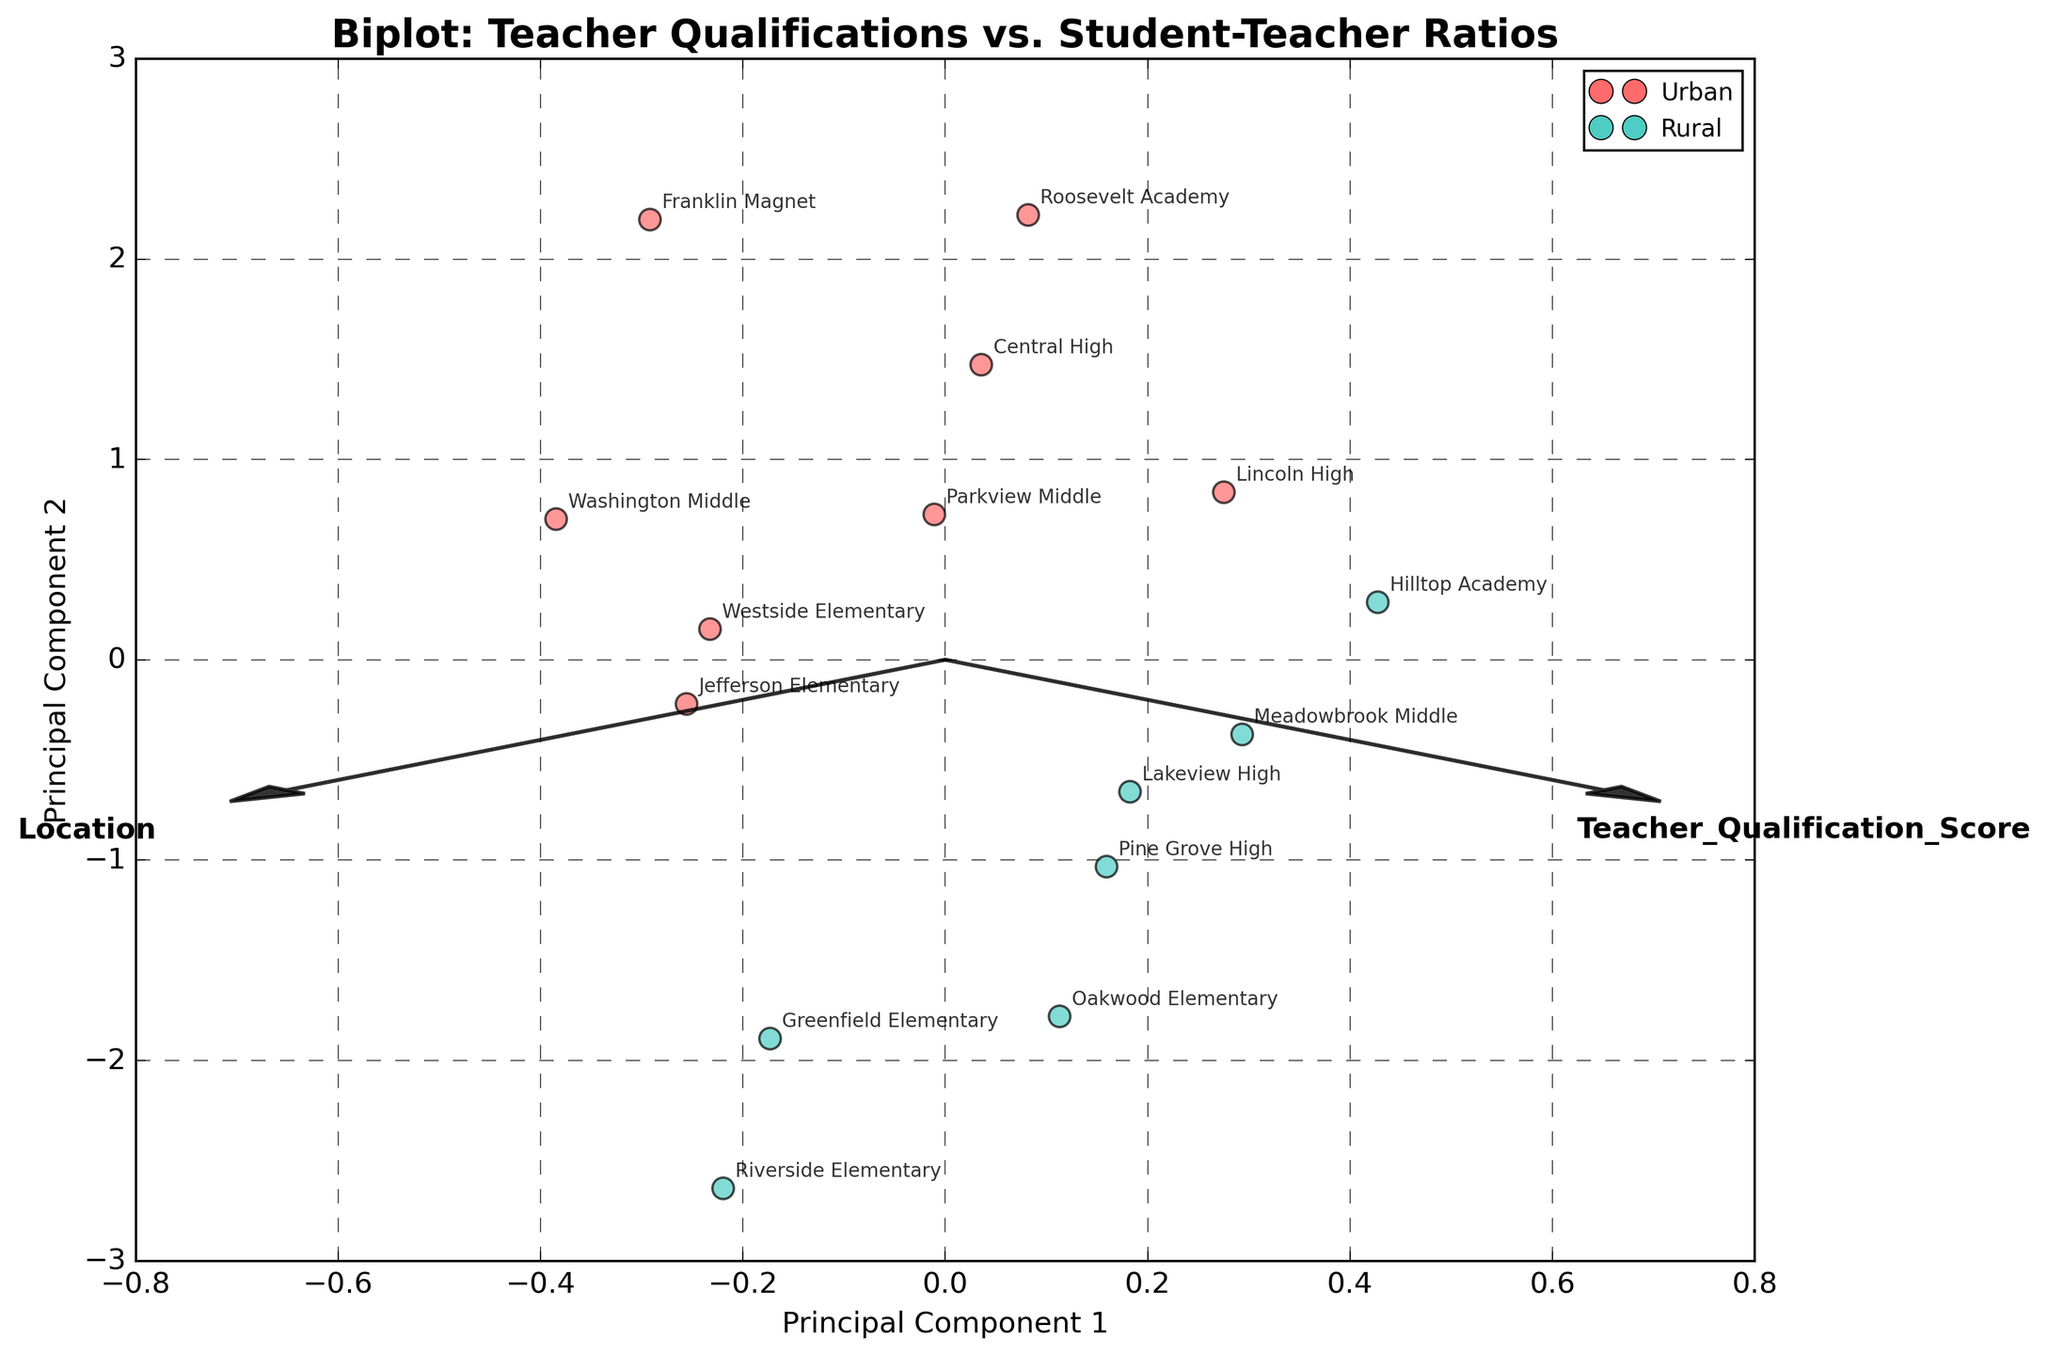Where are the labels for the axes displayed in the plot? The axes labels in the biplot are displayed at the ends of each axis. The x-axis is labeled "Principal Component 1" and the y-axis is labeled "Principal Component 2." These labels help identify the components of each principal axis.
Answer: At the ends of each axis What colors represent the Urban and Rural locations in the plot? In the biplot, Urban locations are represented by a red color, while Rural locations are represented by a teal color. The colors distinguish between the two types of locations for easy identification.
Answer: Red for Urban, Teal for Rural How many Urban and Rural schools are displayed in the plot? By counting the points with red color representing Urban locations and those with teal color representing Rural locations, we can determine the number of schools for each category. There are 8 Urban schools and 7 Rural schools shown in the plot.
Answer: 8 Urban, 7 Rural Which school has the highest Teacher Qualification Score among those displayed, and what is its Student-to-Teacher Ratio? By looking at the projection of points and their labels, Roosevelt Academy has the highest Teacher Qualification Score. It is marked at a higher position on the x and y axis. Its Student-to-Teacher Ratio is 15.
Answer: Roosevelt Academy, Ratio: 15 Compare the average Student-Teacher Ratios of Urban and Rural schools. To find the average, sum the Student-Teacher Ratios for Urban and Rural schools separately and divide by their respective counts. Urban schools (18, 22, 20, 15, 16, 17, 19, 21) sum to 148, and divided by 8 gives 18.5. Rural schools (25, 23, 21, 28, 19, 26, 22) sum to 164, and divided by 7 gives 23.4.
Answer: Urban: 18.5, Rural: 23.4 Is there a general trend between Teacher Qualification Scores and Student-Teacher Ratios in Urban and Rural schools? By observing the biplot, it appears that higher Teacher Qualification Scores tend to be associated with Urban schools, while lower scores align more with Rural schools. Additionally, Urban schools generally have lower Student-Teacher Ratios compared to Rural schools.
Answer: Urban: higher qualifications, lower ratios; Rural: lower qualifications, higher ratios Which schools are closest to the origin in the biplot? Schools closest to the origin would be those whose projections on both principal components are near zero. By looking at the plot, Jefferson Elementary (Urban) and Pine Grove High (Rural) are closest to the origin.
Answer: Jefferson Elementary, Pine Grove High Which two principal components are represented in this biplot, and what do the arrows indicate? The biplot represents Principal Component 1 and Principal Component 2. The arrows indicate the direction and magnitude of the original variables – Teacher Qualification Score and Student-Teacher Ratio – in the new principal component space.
Answer: Principal Component 1 and Principal Component 2; arrows for original variables How do the Teacher Qualification Scores of Urban schools compare to Rural schools based on their projections in the plot? The Urban schools generally show higher projections along the axis corresponding to Teacher Qualification Scores, indicating that the Urban schools have higher qualification scores. Rural schools are projected lower on this axis, indicating lower scores.
Answer: Urban: higher qualifications; Rural: lower qualifications Which school has the highest Student-Teacher Ratio, and does it match the general trend observed between the two regions? Riverside Elementary has the highest Student-Teacher Ratio at 28. This matches the general trend observed where Rural schools have higher Student-Teacher Ratios compared to Urban schools.
Answer: Riverside Elementary, Ratio: 28 